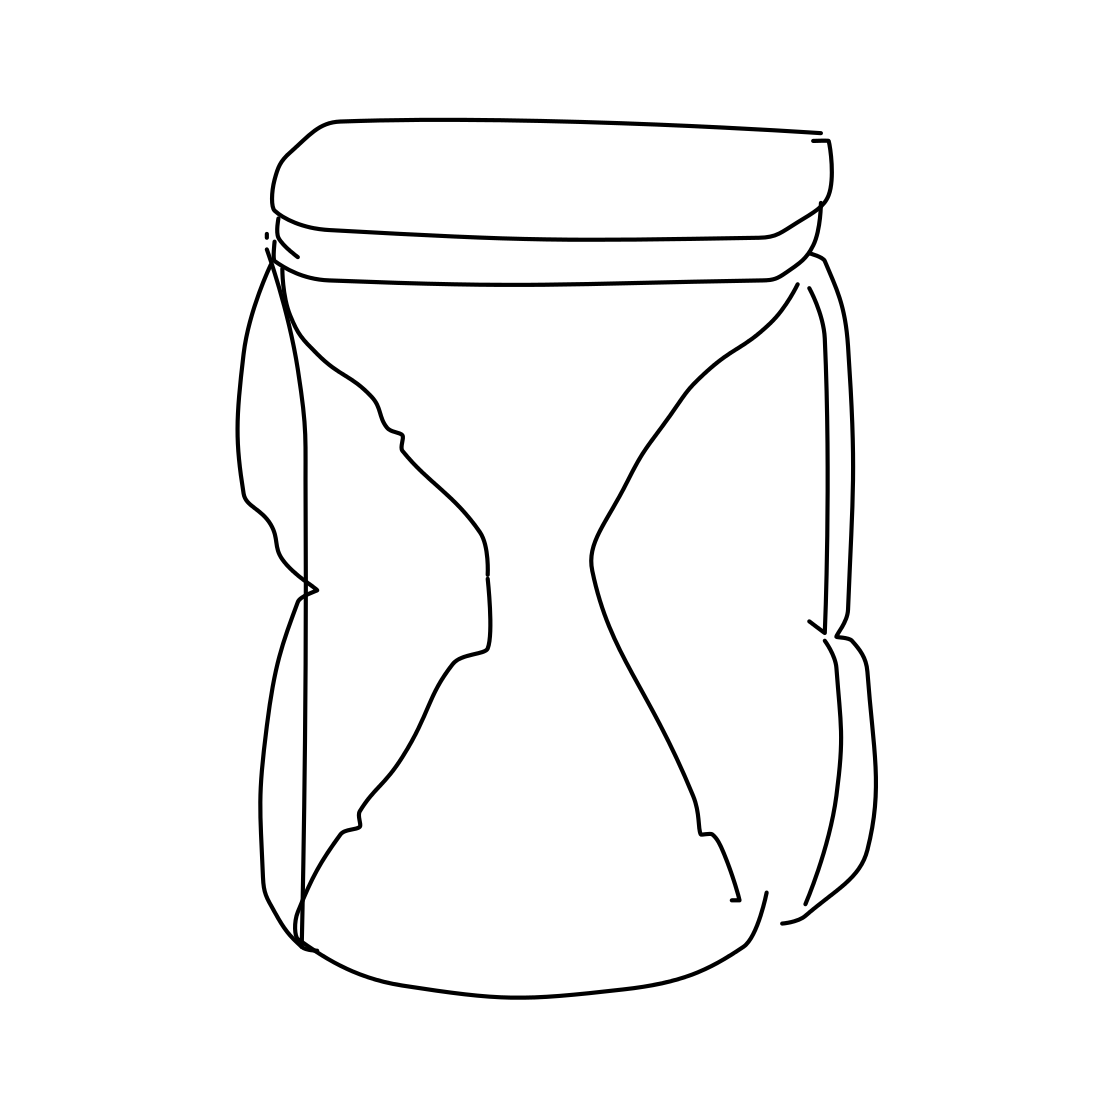What could you use this jar for? This jar, even though it's represented as a drawing, could be used for a variety of purposes if it were real. You might use it to store kitchen items like spices or dry goods, as a vase for flowers, or even as a decorative piece on a shelf. Do you think it's a regular jar or does it have a special design? The jar's design isn't standard; the constriction in the middle gives it a distinctive look that sets it apart from typical straight-sided jars. This design could be purely aesthetic, or it might have a practical function, like providing a better grip. In a real-world setting, this unique shape could make the jar a conversation piece or a more ergonomic container. 